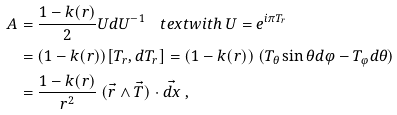<formula> <loc_0><loc_0><loc_500><loc_500>A & = \frac { 1 - k ( r ) } { 2 } U d U ^ { - 1 } \quad t e x t { w i t h } \ U = e ^ { i \pi T _ { r } } \\ & = ( 1 - k ( r ) ) [ T _ { r } , d T _ { r } ] = ( 1 - k ( r ) ) \ ( T _ { \theta } \sin \theta d \varphi - T _ { \varphi } d \theta ) \\ & = \frac { 1 - k ( r ) } { r ^ { 2 } } \ ( \vec { r } \wedge \vec { T } ) \cdot \vec { d x } \ ,</formula> 